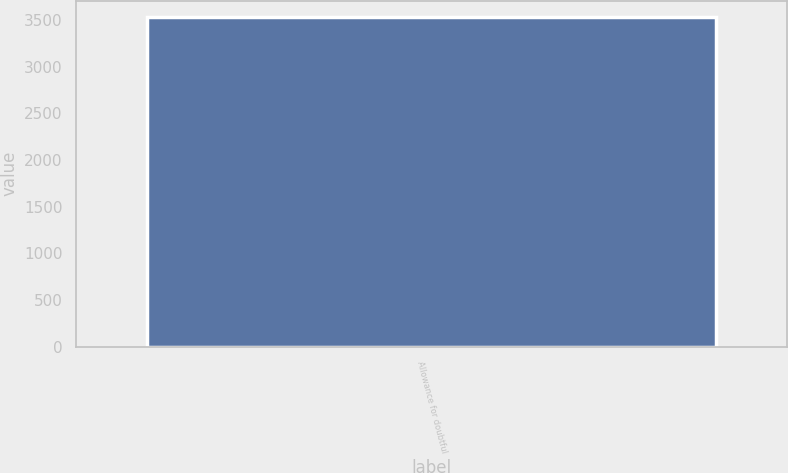Convert chart. <chart><loc_0><loc_0><loc_500><loc_500><bar_chart><fcel>Allowance for doubtful<nl><fcel>3530<nl></chart> 